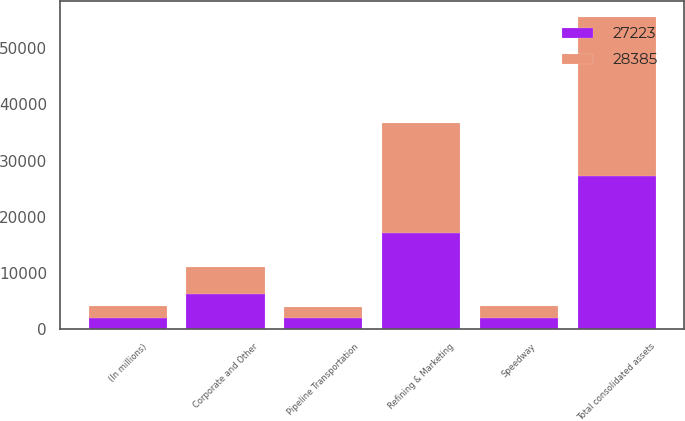Convert chart. <chart><loc_0><loc_0><loc_500><loc_500><stacked_bar_chart><ecel><fcel>(In millions)<fcel>Refining & Marketing<fcel>Speedway<fcel>Pipeline Transportation<fcel>Corporate and Other<fcel>Total consolidated assets<nl><fcel>28385<fcel>2013<fcel>19573<fcel>2064<fcel>1947<fcel>4801<fcel>28385<nl><fcel>27223<fcel>2012<fcel>17052<fcel>1947<fcel>1950<fcel>6274<fcel>27223<nl></chart> 